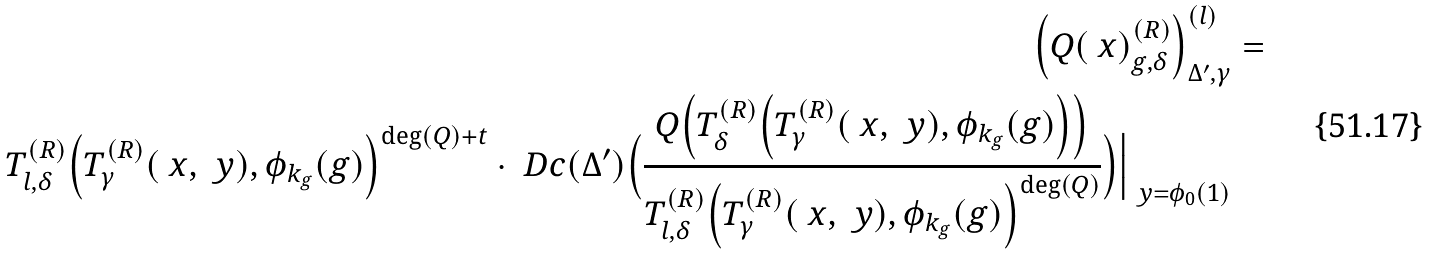Convert formula to latex. <formula><loc_0><loc_0><loc_500><loc_500>\Big ( Q ( \ x ) _ { g , \delta } ^ { ( R ) } \Big ) ^ { ( l ) } _ { \Delta ^ { \prime } , \gamma } & = \\ T ^ { ( R ) } _ { l , \delta } \Big ( T ^ { ( R ) } _ { \gamma } ( \ x , \ y ) , \phi _ { k _ { g } } ( g ) \Big ) ^ { \deg ( Q ) + t } \cdot \ D c ( \Delta ^ { \prime } ) \Big ( \frac { Q \Big ( T ^ { ( R ) } _ { \delta } \Big ( T ^ { ( R ) } _ { \gamma } ( \ x , \ y ) , \phi _ { k _ { g } } ( g ) \Big ) \Big ) } { T ^ { ( R ) } _ { l , \delta } \Big ( T ^ { ( R ) } _ { \gamma } ( \ x , \ y ) , \phi _ { k _ { g } } ( g ) \Big ) ^ { \deg ( Q ) } } \Big ) \Big | _ { \ y = \phi _ { 0 } ( 1 ) } &</formula> 